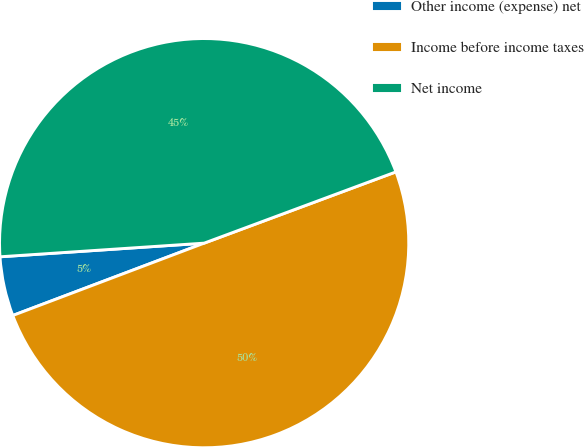Convert chart. <chart><loc_0><loc_0><loc_500><loc_500><pie_chart><fcel>Other income (expense) net<fcel>Income before income taxes<fcel>Net income<nl><fcel>4.69%<fcel>49.91%<fcel>45.4%<nl></chart> 